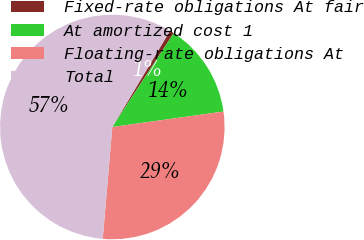Convert chart. <chart><loc_0><loc_0><loc_500><loc_500><pie_chart><fcel>Fixed-rate obligations At fair<fcel>At amortized cost 1<fcel>Floating-rate obligations At<fcel>Total<nl><fcel>0.62%<fcel>13.58%<fcel>28.56%<fcel>57.23%<nl></chart> 